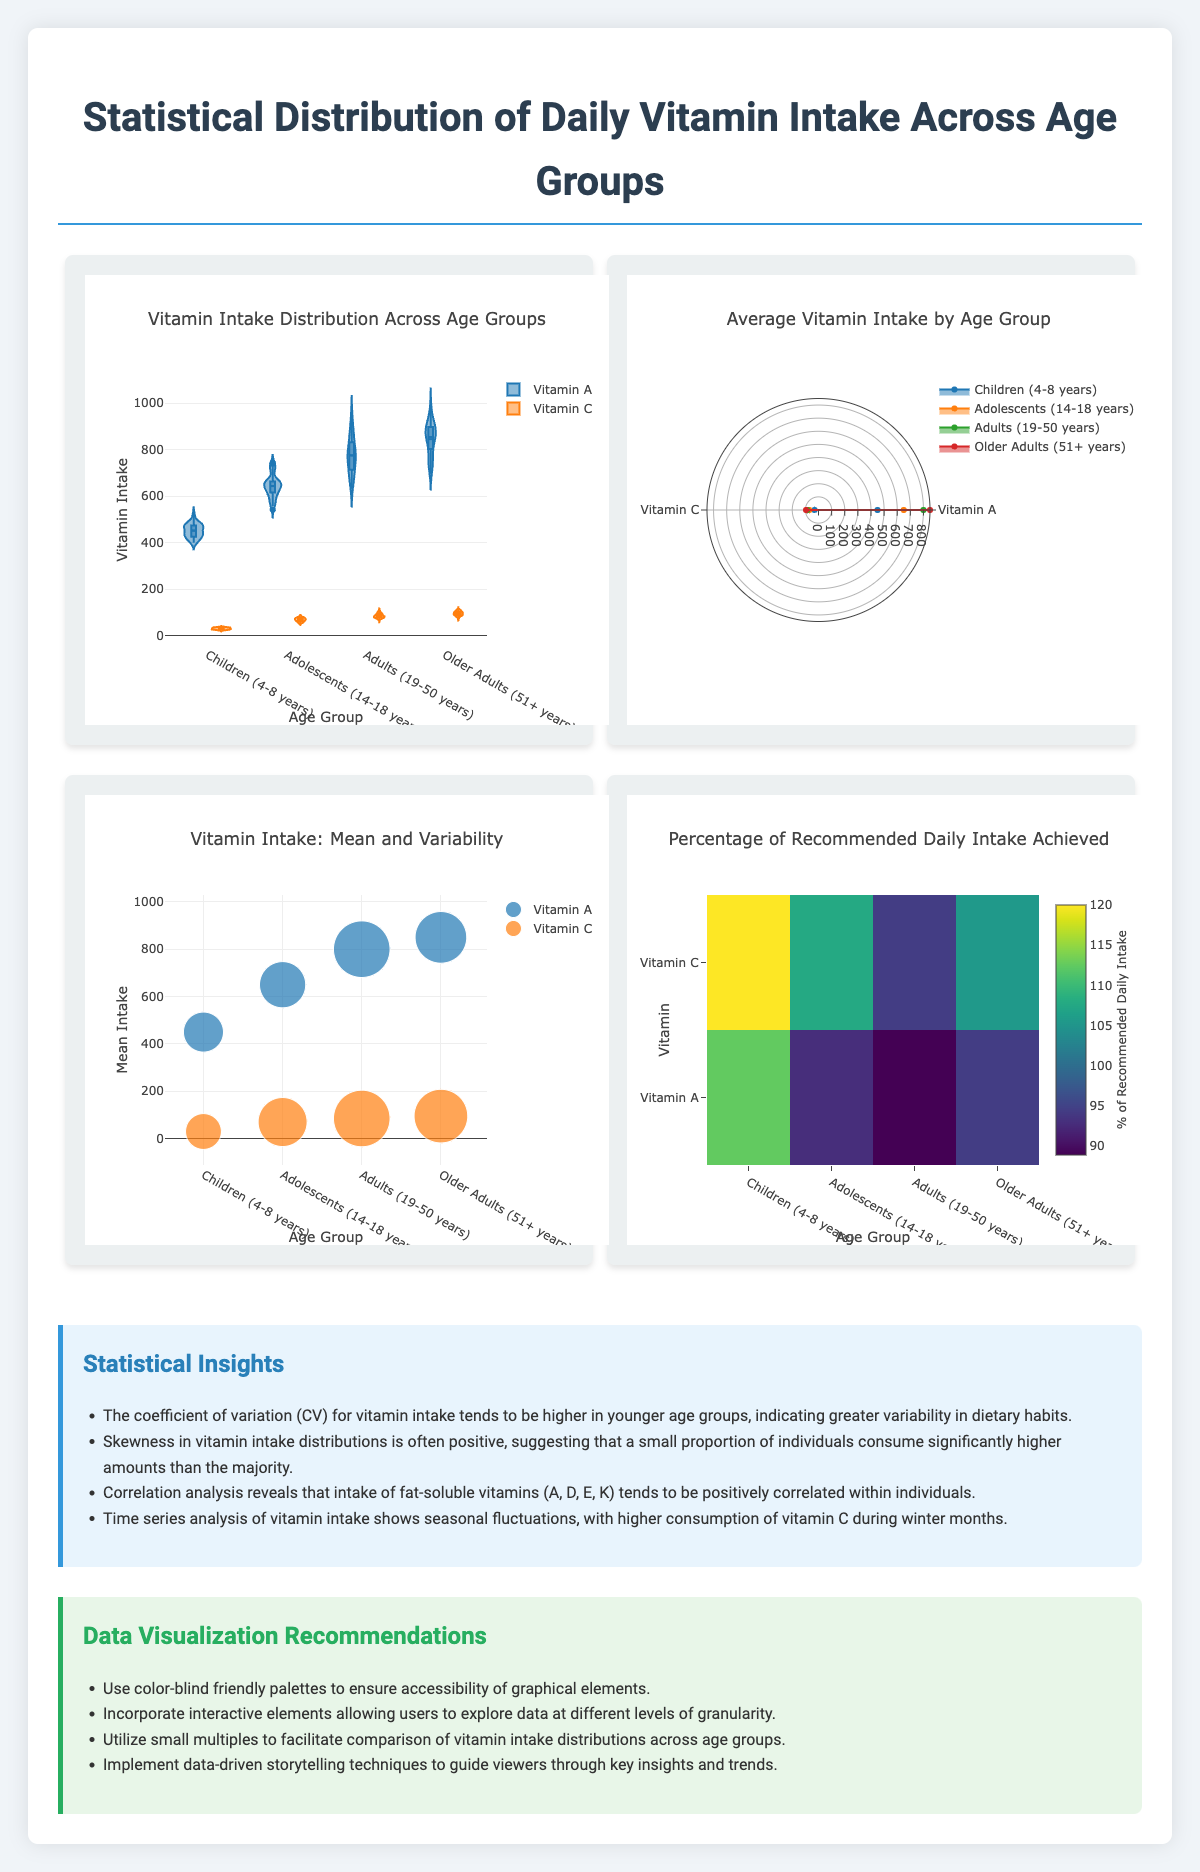which vitamin has the highest mean intake in Adults (19-50 years)? The mean intake for Vitamin A in Adults is 800 mcg RAE, which is higher than the mean intake for Vitamin C, which is 85 mg.
Answer: Vitamin A how many age groups are studied in the document? The document lists four different age groups: Children (4-8 years), Adolescents (14-18 years), Adults (19-50 years), and Older Adults (51+ years).
Answer: 4 which graphical element shows the distribution of vitamin intake for each age group? The Violin Plot combines a box plot and a kernel density plot, which displays the full distribution of vitamin intake for each age group.
Answer: Violin Plot what trend can be observed about vitamin C intake from children to older adults? The mean intake for Vitamin C increases across the age groups: 30 mg for Children, 70 mg for Adolescents, 85 mg for Adults, and 95 mg for Older Adults.
Answer: The mean intake increases with age what is one statistical insight mentioned in the document? This indicates greater variability in dietary habits among younger age groups.
Answer: The coefficient of variation (CV) for vitamin intake tends to be higher in younger age groups what does the heatmap visualize? The heatmap shows a color-coded grid representing how much of the recommended daily intake each age group achieves for different vitamins.
Answer: The percentage of recommended daily intake achieved by each age group for different vitamins which is a characteristic feature of the radar chart? The radar chart is a multi-dimensional chart where each spoke corresponds to a vitamin and it plots the intake levels across different age groups.
Answer: It compares vitamin intake across age groups with each spoke representing a different vitamin which age group has the smallest standard deviation for Vitamin A intake? A. Children B. Adolescents C. Adults D. Older Adults The standard deviation for Vitamin A intake is smallest for Children (75), compared to Adolescents (100), Adults (150), and Older Adults (125).
Answer: A what does the bubble size represent in the bubble chart? A. Mean intake B. Variability C. Number of people in the study D. Age group The size of each bubble represents the standard deviation of vitamin intake, indicating variability for each age group.
Answer: B has the intake of fat-soluble vitamins (A, D, E, K) been found to be positively correlated within individuals? A. Yes B. No C. Not enough information D. Depends on age group The document mentions that correlation analysis reveals a positive correlation in the intake of fat-soluble vitamins within individuals.
Answer: A does the document recommend using interactive elements in data visualization? One of the recommendations is to incorporate interactive elements to allow users to explore data at different levels of granularity.
Answer: Yes what is the main idea of this document? It includes data on vitamin intake for various age groups, uses unique graphical elements to visualize this data, and offers insights and recommendations for clearer and more accessible data communication.
Answer: The document details the statistical distribution of daily vitamin intake across different age groups using innovative graphical elements, and provides insights and recommendations for effective data visualization. what methodology was used to collect the data presented? The document does not provide details about the methodology used to collect the vitamin intake data across different age groups.
Answer: Not enough information 